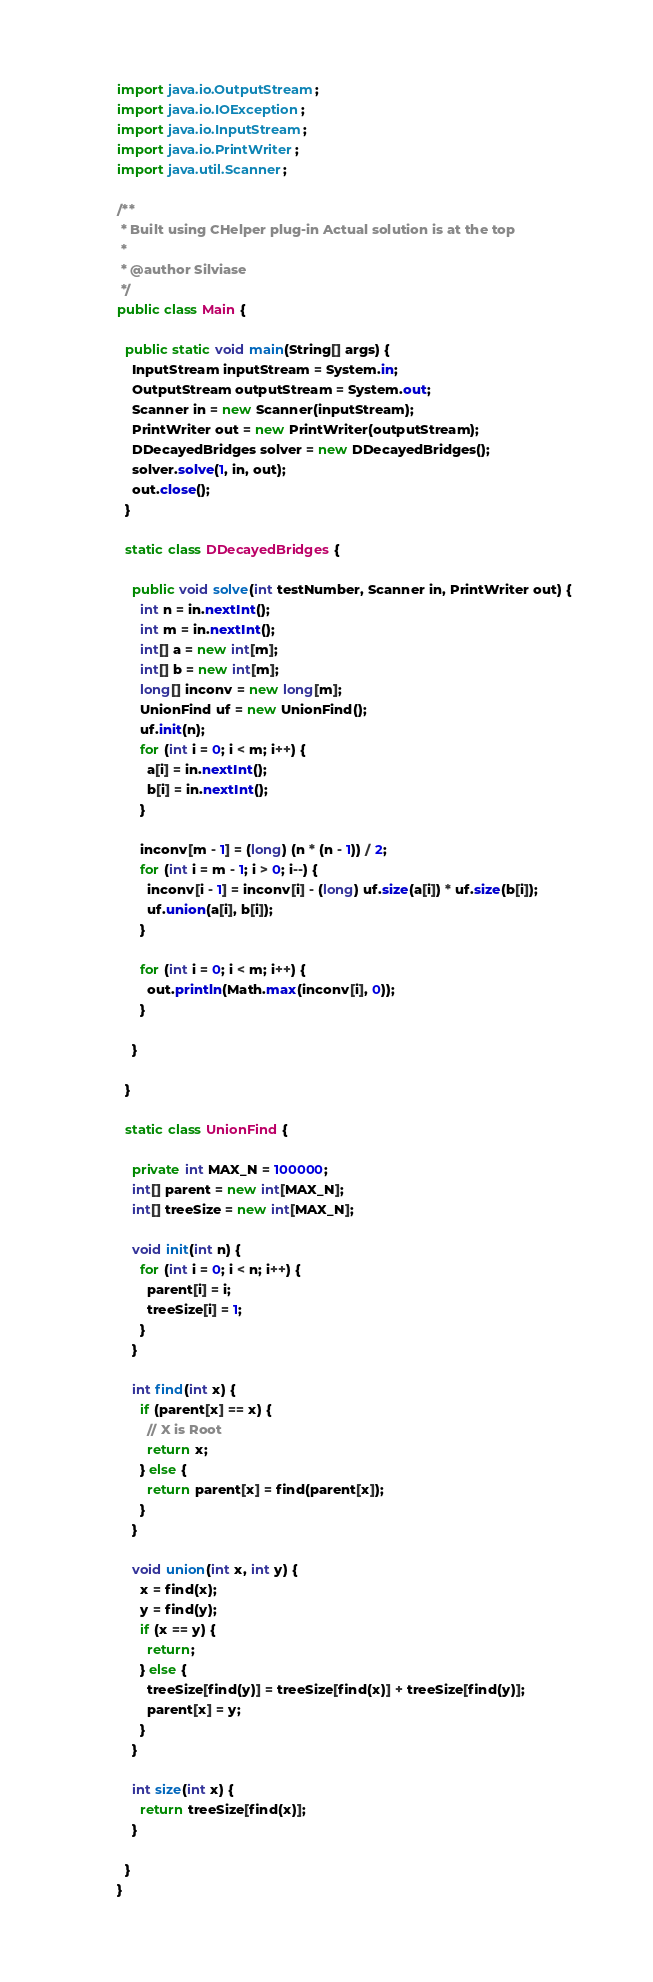<code> <loc_0><loc_0><loc_500><loc_500><_Java_>import java.io.OutputStream;
import java.io.IOException;
import java.io.InputStream;
import java.io.PrintWriter;
import java.util.Scanner;

/**
 * Built using CHelper plug-in Actual solution is at the top
 *
 * @author Silviase
 */
public class Main {

  public static void main(String[] args) {
    InputStream inputStream = System.in;
    OutputStream outputStream = System.out;
    Scanner in = new Scanner(inputStream);
    PrintWriter out = new PrintWriter(outputStream);
    DDecayedBridges solver = new DDecayedBridges();
    solver.solve(1, in, out);
    out.close();
  }

  static class DDecayedBridges {

    public void solve(int testNumber, Scanner in, PrintWriter out) {
      int n = in.nextInt();
      int m = in.nextInt();
      int[] a = new int[m];
      int[] b = new int[m];
      long[] inconv = new long[m];
      UnionFind uf = new UnionFind();
      uf.init(n);
      for (int i = 0; i < m; i++) {
        a[i] = in.nextInt();
        b[i] = in.nextInt();
      }

      inconv[m - 1] = (long) (n * (n - 1)) / 2;
      for (int i = m - 1; i > 0; i--) {
        inconv[i - 1] = inconv[i] - (long) uf.size(a[i]) * uf.size(b[i]);
        uf.union(a[i], b[i]);
      }

      for (int i = 0; i < m; i++) {
        out.println(Math.max(inconv[i], 0));
      }

    }

  }

  static class UnionFind {

    private int MAX_N = 100000;
    int[] parent = new int[MAX_N];
    int[] treeSize = new int[MAX_N];

    void init(int n) {
      for (int i = 0; i < n; i++) {
        parent[i] = i;
        treeSize[i] = 1;
      }
    }

    int find(int x) {
      if (parent[x] == x) {
        // X is Root
        return x;
      } else {
        return parent[x] = find(parent[x]);
      }
    }

    void union(int x, int y) {
      x = find(x);
      y = find(y);
      if (x == y) {
        return;
      } else {
        treeSize[find(y)] = treeSize[find(x)] + treeSize[find(y)];
        parent[x] = y;
      }
    }

    int size(int x) {
      return treeSize[find(x)];
    }

  }
}

</code> 